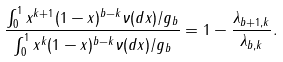Convert formula to latex. <formula><loc_0><loc_0><loc_500><loc_500>\frac { \int _ { 0 } ^ { 1 } x ^ { k + 1 } ( 1 - x ) ^ { b - k } \nu ( d x ) / g _ { b } } { \int _ { 0 } ^ { 1 } x ^ { k } ( 1 - x ) ^ { b - k } \nu ( d x ) / g _ { b } } = 1 - \frac { \lambda _ { b + 1 , k } } { \lambda _ { b , k } } .</formula> 